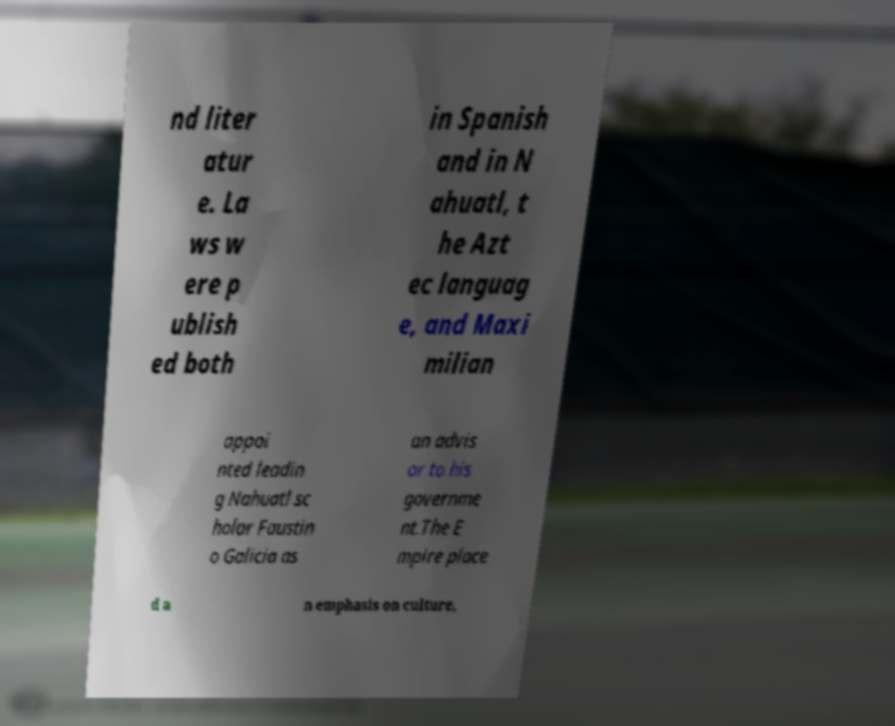Please read and relay the text visible in this image. What does it say? nd liter atur e. La ws w ere p ublish ed both in Spanish and in N ahuatl, t he Azt ec languag e, and Maxi milian appoi nted leadin g Nahuatl sc holar Faustin o Galicia as an advis or to his governme nt.The E mpire place d a n emphasis on culture, 